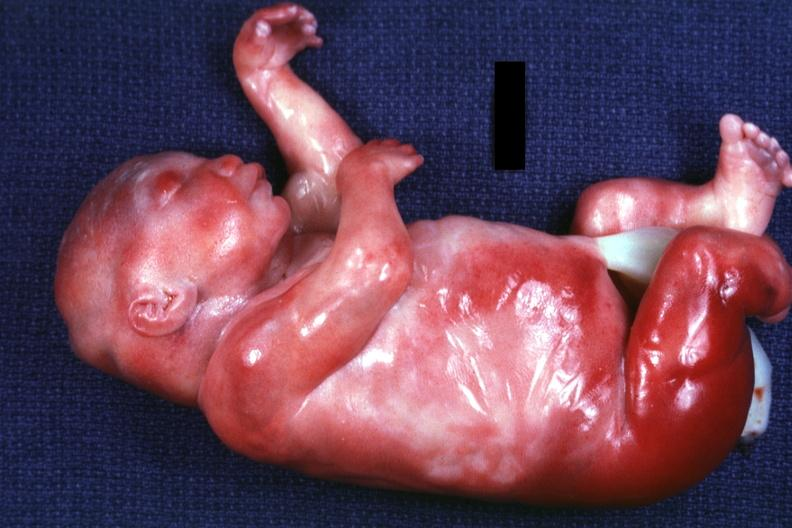does peritoneum show lateral view of body with renal facies no neck?
Answer the question using a single word or phrase. No 